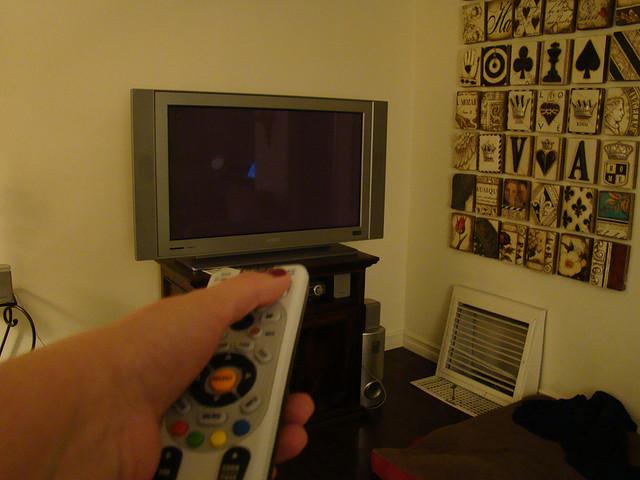Is the tv on?
Concise answer only. No. Where is the art?
Be succinct. On wall. What brand TV is this?
Keep it brief. Sony. 